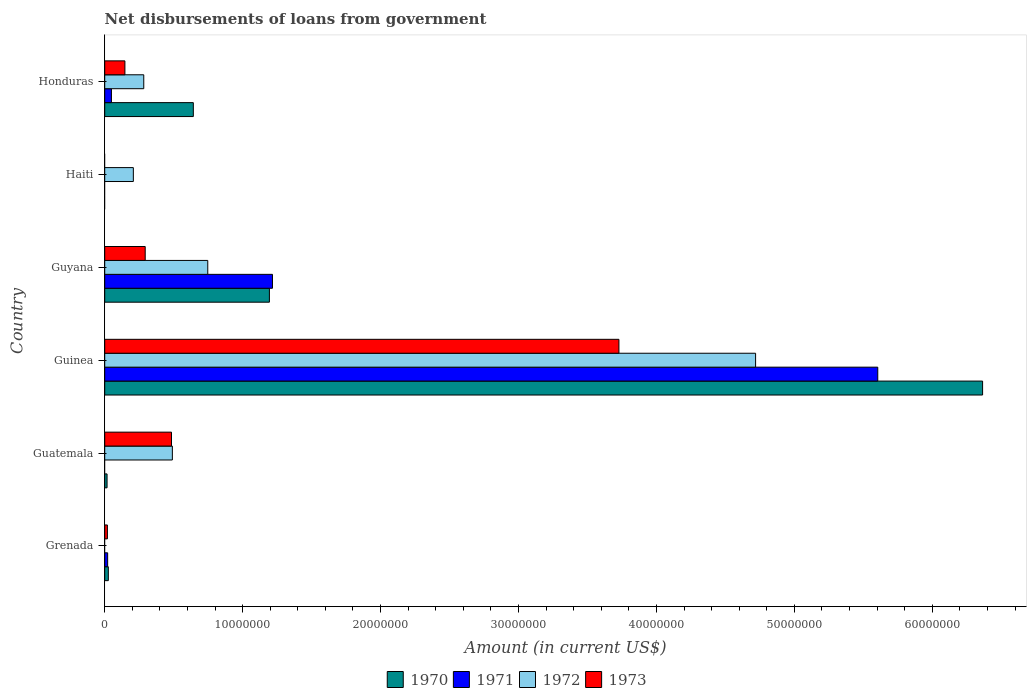Are the number of bars on each tick of the Y-axis equal?
Ensure brevity in your answer.  No. What is the label of the 3rd group of bars from the top?
Offer a terse response. Guyana. In how many cases, is the number of bars for a given country not equal to the number of legend labels?
Offer a very short reply. 3. What is the amount of loan disbursed from government in 1971 in Grenada?
Your answer should be very brief. 2.13e+05. Across all countries, what is the maximum amount of loan disbursed from government in 1970?
Your answer should be very brief. 6.36e+07. In which country was the amount of loan disbursed from government in 1971 maximum?
Your answer should be very brief. Guinea. What is the total amount of loan disbursed from government in 1971 in the graph?
Your answer should be compact. 6.89e+07. What is the difference between the amount of loan disbursed from government in 1972 in Guatemala and that in Guyana?
Ensure brevity in your answer.  -2.57e+06. What is the difference between the amount of loan disbursed from government in 1972 in Grenada and the amount of loan disbursed from government in 1970 in Honduras?
Provide a short and direct response. -6.42e+06. What is the average amount of loan disbursed from government in 1972 per country?
Provide a short and direct response. 1.07e+07. What is the difference between the amount of loan disbursed from government in 1971 and amount of loan disbursed from government in 1972 in Guyana?
Provide a succinct answer. 4.69e+06. What is the ratio of the amount of loan disbursed from government in 1973 in Guyana to that in Honduras?
Your answer should be compact. 2. What is the difference between the highest and the second highest amount of loan disbursed from government in 1971?
Your answer should be compact. 4.39e+07. What is the difference between the highest and the lowest amount of loan disbursed from government in 1971?
Your response must be concise. 5.60e+07. In how many countries, is the amount of loan disbursed from government in 1970 greater than the average amount of loan disbursed from government in 1970 taken over all countries?
Offer a terse response. 1. Is the sum of the amount of loan disbursed from government in 1973 in Grenada and Guinea greater than the maximum amount of loan disbursed from government in 1970 across all countries?
Offer a very short reply. No. Is it the case that in every country, the sum of the amount of loan disbursed from government in 1971 and amount of loan disbursed from government in 1970 is greater than the amount of loan disbursed from government in 1972?
Offer a very short reply. No. How many countries are there in the graph?
Your response must be concise. 6. What is the difference between two consecutive major ticks on the X-axis?
Your answer should be very brief. 1.00e+07. Are the values on the major ticks of X-axis written in scientific E-notation?
Your answer should be very brief. No. Does the graph contain grids?
Give a very brief answer. No. What is the title of the graph?
Give a very brief answer. Net disbursements of loans from government. Does "2000" appear as one of the legend labels in the graph?
Your answer should be compact. No. What is the label or title of the X-axis?
Offer a terse response. Amount (in current US$). What is the label or title of the Y-axis?
Your response must be concise. Country. What is the Amount (in current US$) in 1970 in Grenada?
Provide a succinct answer. 2.62e+05. What is the Amount (in current US$) of 1971 in Grenada?
Offer a terse response. 2.13e+05. What is the Amount (in current US$) in 1972 in Grenada?
Your answer should be compact. 0. What is the Amount (in current US$) of 1973 in Grenada?
Provide a short and direct response. 1.95e+05. What is the Amount (in current US$) in 1972 in Guatemala?
Provide a succinct answer. 4.90e+06. What is the Amount (in current US$) of 1973 in Guatemala?
Give a very brief answer. 4.84e+06. What is the Amount (in current US$) in 1970 in Guinea?
Your answer should be very brief. 6.36e+07. What is the Amount (in current US$) in 1971 in Guinea?
Your response must be concise. 5.60e+07. What is the Amount (in current US$) of 1972 in Guinea?
Your answer should be compact. 4.72e+07. What is the Amount (in current US$) of 1973 in Guinea?
Make the answer very short. 3.73e+07. What is the Amount (in current US$) in 1970 in Guyana?
Offer a very short reply. 1.19e+07. What is the Amount (in current US$) of 1971 in Guyana?
Offer a terse response. 1.22e+07. What is the Amount (in current US$) of 1972 in Guyana?
Keep it short and to the point. 7.47e+06. What is the Amount (in current US$) in 1973 in Guyana?
Give a very brief answer. 2.94e+06. What is the Amount (in current US$) in 1970 in Haiti?
Ensure brevity in your answer.  0. What is the Amount (in current US$) in 1972 in Haiti?
Provide a succinct answer. 2.08e+06. What is the Amount (in current US$) of 1970 in Honduras?
Offer a very short reply. 6.42e+06. What is the Amount (in current US$) in 1971 in Honduras?
Make the answer very short. 4.87e+05. What is the Amount (in current US$) of 1972 in Honduras?
Give a very brief answer. 2.83e+06. What is the Amount (in current US$) in 1973 in Honduras?
Ensure brevity in your answer.  1.46e+06. Across all countries, what is the maximum Amount (in current US$) in 1970?
Ensure brevity in your answer.  6.36e+07. Across all countries, what is the maximum Amount (in current US$) of 1971?
Your answer should be very brief. 5.60e+07. Across all countries, what is the maximum Amount (in current US$) in 1972?
Ensure brevity in your answer.  4.72e+07. Across all countries, what is the maximum Amount (in current US$) of 1973?
Ensure brevity in your answer.  3.73e+07. Across all countries, what is the minimum Amount (in current US$) of 1970?
Ensure brevity in your answer.  0. Across all countries, what is the minimum Amount (in current US$) in 1972?
Keep it short and to the point. 0. Across all countries, what is the minimum Amount (in current US$) of 1973?
Provide a short and direct response. 0. What is the total Amount (in current US$) of 1970 in the graph?
Make the answer very short. 8.24e+07. What is the total Amount (in current US$) in 1971 in the graph?
Keep it short and to the point. 6.89e+07. What is the total Amount (in current US$) in 1972 in the graph?
Offer a very short reply. 6.45e+07. What is the total Amount (in current US$) in 1973 in the graph?
Your response must be concise. 4.67e+07. What is the difference between the Amount (in current US$) of 1970 in Grenada and that in Guatemala?
Your answer should be very brief. 9.20e+04. What is the difference between the Amount (in current US$) of 1973 in Grenada and that in Guatemala?
Your response must be concise. -4.65e+06. What is the difference between the Amount (in current US$) in 1970 in Grenada and that in Guinea?
Make the answer very short. -6.34e+07. What is the difference between the Amount (in current US$) of 1971 in Grenada and that in Guinea?
Your answer should be very brief. -5.58e+07. What is the difference between the Amount (in current US$) in 1973 in Grenada and that in Guinea?
Offer a terse response. -3.71e+07. What is the difference between the Amount (in current US$) in 1970 in Grenada and that in Guyana?
Your answer should be compact. -1.17e+07. What is the difference between the Amount (in current US$) of 1971 in Grenada and that in Guyana?
Ensure brevity in your answer.  -1.19e+07. What is the difference between the Amount (in current US$) in 1973 in Grenada and that in Guyana?
Ensure brevity in your answer.  -2.74e+06. What is the difference between the Amount (in current US$) in 1970 in Grenada and that in Honduras?
Make the answer very short. -6.16e+06. What is the difference between the Amount (in current US$) of 1971 in Grenada and that in Honduras?
Your answer should be very brief. -2.74e+05. What is the difference between the Amount (in current US$) of 1973 in Grenada and that in Honduras?
Your response must be concise. -1.27e+06. What is the difference between the Amount (in current US$) in 1970 in Guatemala and that in Guinea?
Offer a very short reply. -6.35e+07. What is the difference between the Amount (in current US$) of 1972 in Guatemala and that in Guinea?
Your response must be concise. -4.23e+07. What is the difference between the Amount (in current US$) in 1973 in Guatemala and that in Guinea?
Ensure brevity in your answer.  -3.24e+07. What is the difference between the Amount (in current US$) of 1970 in Guatemala and that in Guyana?
Make the answer very short. -1.18e+07. What is the difference between the Amount (in current US$) of 1972 in Guatemala and that in Guyana?
Ensure brevity in your answer.  -2.57e+06. What is the difference between the Amount (in current US$) in 1973 in Guatemala and that in Guyana?
Your answer should be very brief. 1.91e+06. What is the difference between the Amount (in current US$) in 1972 in Guatemala and that in Haiti?
Your response must be concise. 2.83e+06. What is the difference between the Amount (in current US$) in 1970 in Guatemala and that in Honduras?
Make the answer very short. -6.25e+06. What is the difference between the Amount (in current US$) in 1972 in Guatemala and that in Honduras?
Keep it short and to the point. 2.07e+06. What is the difference between the Amount (in current US$) in 1973 in Guatemala and that in Honduras?
Your answer should be very brief. 3.38e+06. What is the difference between the Amount (in current US$) of 1970 in Guinea and that in Guyana?
Your response must be concise. 5.17e+07. What is the difference between the Amount (in current US$) of 1971 in Guinea and that in Guyana?
Give a very brief answer. 4.39e+07. What is the difference between the Amount (in current US$) in 1972 in Guinea and that in Guyana?
Give a very brief answer. 3.97e+07. What is the difference between the Amount (in current US$) in 1973 in Guinea and that in Guyana?
Your response must be concise. 3.43e+07. What is the difference between the Amount (in current US$) in 1972 in Guinea and that in Haiti?
Provide a succinct answer. 4.51e+07. What is the difference between the Amount (in current US$) of 1970 in Guinea and that in Honduras?
Give a very brief answer. 5.72e+07. What is the difference between the Amount (in current US$) in 1971 in Guinea and that in Honduras?
Ensure brevity in your answer.  5.56e+07. What is the difference between the Amount (in current US$) of 1972 in Guinea and that in Honduras?
Offer a terse response. 4.44e+07. What is the difference between the Amount (in current US$) of 1973 in Guinea and that in Honduras?
Provide a short and direct response. 3.58e+07. What is the difference between the Amount (in current US$) in 1972 in Guyana and that in Haiti?
Your answer should be compact. 5.40e+06. What is the difference between the Amount (in current US$) in 1970 in Guyana and that in Honduras?
Give a very brief answer. 5.52e+06. What is the difference between the Amount (in current US$) in 1971 in Guyana and that in Honduras?
Offer a very short reply. 1.17e+07. What is the difference between the Amount (in current US$) in 1972 in Guyana and that in Honduras?
Offer a terse response. 4.64e+06. What is the difference between the Amount (in current US$) of 1973 in Guyana and that in Honduras?
Your answer should be compact. 1.47e+06. What is the difference between the Amount (in current US$) in 1972 in Haiti and that in Honduras?
Your answer should be compact. -7.55e+05. What is the difference between the Amount (in current US$) of 1970 in Grenada and the Amount (in current US$) of 1972 in Guatemala?
Ensure brevity in your answer.  -4.64e+06. What is the difference between the Amount (in current US$) in 1970 in Grenada and the Amount (in current US$) in 1973 in Guatemala?
Your response must be concise. -4.58e+06. What is the difference between the Amount (in current US$) in 1971 in Grenada and the Amount (in current US$) in 1972 in Guatemala?
Your answer should be very brief. -4.69e+06. What is the difference between the Amount (in current US$) of 1971 in Grenada and the Amount (in current US$) of 1973 in Guatemala?
Offer a terse response. -4.63e+06. What is the difference between the Amount (in current US$) in 1970 in Grenada and the Amount (in current US$) in 1971 in Guinea?
Give a very brief answer. -5.58e+07. What is the difference between the Amount (in current US$) in 1970 in Grenada and the Amount (in current US$) in 1972 in Guinea?
Ensure brevity in your answer.  -4.69e+07. What is the difference between the Amount (in current US$) of 1970 in Grenada and the Amount (in current US$) of 1973 in Guinea?
Give a very brief answer. -3.70e+07. What is the difference between the Amount (in current US$) in 1971 in Grenada and the Amount (in current US$) in 1972 in Guinea?
Ensure brevity in your answer.  -4.70e+07. What is the difference between the Amount (in current US$) of 1971 in Grenada and the Amount (in current US$) of 1973 in Guinea?
Offer a very short reply. -3.71e+07. What is the difference between the Amount (in current US$) in 1970 in Grenada and the Amount (in current US$) in 1971 in Guyana?
Ensure brevity in your answer.  -1.19e+07. What is the difference between the Amount (in current US$) of 1970 in Grenada and the Amount (in current US$) of 1972 in Guyana?
Keep it short and to the point. -7.21e+06. What is the difference between the Amount (in current US$) in 1970 in Grenada and the Amount (in current US$) in 1973 in Guyana?
Provide a short and direct response. -2.67e+06. What is the difference between the Amount (in current US$) in 1971 in Grenada and the Amount (in current US$) in 1972 in Guyana?
Make the answer very short. -7.26e+06. What is the difference between the Amount (in current US$) in 1971 in Grenada and the Amount (in current US$) in 1973 in Guyana?
Offer a terse response. -2.72e+06. What is the difference between the Amount (in current US$) in 1970 in Grenada and the Amount (in current US$) in 1972 in Haiti?
Your answer should be compact. -1.81e+06. What is the difference between the Amount (in current US$) in 1971 in Grenada and the Amount (in current US$) in 1972 in Haiti?
Your response must be concise. -1.86e+06. What is the difference between the Amount (in current US$) in 1970 in Grenada and the Amount (in current US$) in 1971 in Honduras?
Offer a terse response. -2.25e+05. What is the difference between the Amount (in current US$) of 1970 in Grenada and the Amount (in current US$) of 1972 in Honduras?
Provide a succinct answer. -2.57e+06. What is the difference between the Amount (in current US$) in 1970 in Grenada and the Amount (in current US$) in 1973 in Honduras?
Your response must be concise. -1.20e+06. What is the difference between the Amount (in current US$) of 1971 in Grenada and the Amount (in current US$) of 1972 in Honduras?
Keep it short and to the point. -2.62e+06. What is the difference between the Amount (in current US$) of 1971 in Grenada and the Amount (in current US$) of 1973 in Honduras?
Offer a terse response. -1.25e+06. What is the difference between the Amount (in current US$) of 1970 in Guatemala and the Amount (in current US$) of 1971 in Guinea?
Provide a succinct answer. -5.59e+07. What is the difference between the Amount (in current US$) in 1970 in Guatemala and the Amount (in current US$) in 1972 in Guinea?
Your answer should be very brief. -4.70e+07. What is the difference between the Amount (in current US$) of 1970 in Guatemala and the Amount (in current US$) of 1973 in Guinea?
Offer a very short reply. -3.71e+07. What is the difference between the Amount (in current US$) in 1972 in Guatemala and the Amount (in current US$) in 1973 in Guinea?
Provide a short and direct response. -3.24e+07. What is the difference between the Amount (in current US$) in 1970 in Guatemala and the Amount (in current US$) in 1971 in Guyana?
Provide a succinct answer. -1.20e+07. What is the difference between the Amount (in current US$) in 1970 in Guatemala and the Amount (in current US$) in 1972 in Guyana?
Provide a succinct answer. -7.30e+06. What is the difference between the Amount (in current US$) of 1970 in Guatemala and the Amount (in current US$) of 1973 in Guyana?
Your response must be concise. -2.76e+06. What is the difference between the Amount (in current US$) of 1972 in Guatemala and the Amount (in current US$) of 1973 in Guyana?
Your answer should be very brief. 1.97e+06. What is the difference between the Amount (in current US$) of 1970 in Guatemala and the Amount (in current US$) of 1972 in Haiti?
Keep it short and to the point. -1.91e+06. What is the difference between the Amount (in current US$) in 1970 in Guatemala and the Amount (in current US$) in 1971 in Honduras?
Provide a short and direct response. -3.17e+05. What is the difference between the Amount (in current US$) of 1970 in Guatemala and the Amount (in current US$) of 1972 in Honduras?
Your answer should be compact. -2.66e+06. What is the difference between the Amount (in current US$) in 1970 in Guatemala and the Amount (in current US$) in 1973 in Honduras?
Keep it short and to the point. -1.29e+06. What is the difference between the Amount (in current US$) in 1972 in Guatemala and the Amount (in current US$) in 1973 in Honduras?
Ensure brevity in your answer.  3.44e+06. What is the difference between the Amount (in current US$) in 1970 in Guinea and the Amount (in current US$) in 1971 in Guyana?
Offer a terse response. 5.15e+07. What is the difference between the Amount (in current US$) in 1970 in Guinea and the Amount (in current US$) in 1972 in Guyana?
Offer a very short reply. 5.62e+07. What is the difference between the Amount (in current US$) of 1970 in Guinea and the Amount (in current US$) of 1973 in Guyana?
Provide a succinct answer. 6.07e+07. What is the difference between the Amount (in current US$) in 1971 in Guinea and the Amount (in current US$) in 1972 in Guyana?
Your answer should be very brief. 4.86e+07. What is the difference between the Amount (in current US$) in 1971 in Guinea and the Amount (in current US$) in 1973 in Guyana?
Make the answer very short. 5.31e+07. What is the difference between the Amount (in current US$) in 1972 in Guinea and the Amount (in current US$) in 1973 in Guyana?
Offer a terse response. 4.43e+07. What is the difference between the Amount (in current US$) in 1970 in Guinea and the Amount (in current US$) in 1972 in Haiti?
Provide a short and direct response. 6.16e+07. What is the difference between the Amount (in current US$) of 1971 in Guinea and the Amount (in current US$) of 1972 in Haiti?
Offer a terse response. 5.40e+07. What is the difference between the Amount (in current US$) in 1970 in Guinea and the Amount (in current US$) in 1971 in Honduras?
Offer a very short reply. 6.32e+07. What is the difference between the Amount (in current US$) of 1970 in Guinea and the Amount (in current US$) of 1972 in Honduras?
Provide a succinct answer. 6.08e+07. What is the difference between the Amount (in current US$) of 1970 in Guinea and the Amount (in current US$) of 1973 in Honduras?
Offer a terse response. 6.22e+07. What is the difference between the Amount (in current US$) in 1971 in Guinea and the Amount (in current US$) in 1972 in Honduras?
Offer a terse response. 5.32e+07. What is the difference between the Amount (in current US$) in 1971 in Guinea and the Amount (in current US$) in 1973 in Honduras?
Provide a short and direct response. 5.46e+07. What is the difference between the Amount (in current US$) of 1972 in Guinea and the Amount (in current US$) of 1973 in Honduras?
Provide a short and direct response. 4.57e+07. What is the difference between the Amount (in current US$) of 1970 in Guyana and the Amount (in current US$) of 1972 in Haiti?
Your answer should be compact. 9.86e+06. What is the difference between the Amount (in current US$) of 1971 in Guyana and the Amount (in current US$) of 1972 in Haiti?
Provide a succinct answer. 1.01e+07. What is the difference between the Amount (in current US$) of 1970 in Guyana and the Amount (in current US$) of 1971 in Honduras?
Provide a short and direct response. 1.15e+07. What is the difference between the Amount (in current US$) of 1970 in Guyana and the Amount (in current US$) of 1972 in Honduras?
Give a very brief answer. 9.11e+06. What is the difference between the Amount (in current US$) in 1970 in Guyana and the Amount (in current US$) in 1973 in Honduras?
Keep it short and to the point. 1.05e+07. What is the difference between the Amount (in current US$) in 1971 in Guyana and the Amount (in current US$) in 1972 in Honduras?
Offer a terse response. 9.33e+06. What is the difference between the Amount (in current US$) of 1971 in Guyana and the Amount (in current US$) of 1973 in Honduras?
Provide a short and direct response. 1.07e+07. What is the difference between the Amount (in current US$) in 1972 in Guyana and the Amount (in current US$) in 1973 in Honduras?
Your answer should be compact. 6.01e+06. What is the difference between the Amount (in current US$) of 1972 in Haiti and the Amount (in current US$) of 1973 in Honduras?
Provide a short and direct response. 6.12e+05. What is the average Amount (in current US$) of 1970 per country?
Provide a short and direct response. 1.37e+07. What is the average Amount (in current US$) in 1971 per country?
Offer a terse response. 1.15e+07. What is the average Amount (in current US$) of 1972 per country?
Make the answer very short. 1.07e+07. What is the average Amount (in current US$) in 1973 per country?
Your answer should be very brief. 7.79e+06. What is the difference between the Amount (in current US$) in 1970 and Amount (in current US$) in 1971 in Grenada?
Your answer should be compact. 4.90e+04. What is the difference between the Amount (in current US$) in 1970 and Amount (in current US$) in 1973 in Grenada?
Your answer should be very brief. 6.70e+04. What is the difference between the Amount (in current US$) of 1971 and Amount (in current US$) of 1973 in Grenada?
Provide a succinct answer. 1.80e+04. What is the difference between the Amount (in current US$) in 1970 and Amount (in current US$) in 1972 in Guatemala?
Provide a short and direct response. -4.73e+06. What is the difference between the Amount (in current US$) of 1970 and Amount (in current US$) of 1973 in Guatemala?
Make the answer very short. -4.67e+06. What is the difference between the Amount (in current US$) of 1972 and Amount (in current US$) of 1973 in Guatemala?
Your answer should be very brief. 6.20e+04. What is the difference between the Amount (in current US$) in 1970 and Amount (in current US$) in 1971 in Guinea?
Your response must be concise. 7.60e+06. What is the difference between the Amount (in current US$) in 1970 and Amount (in current US$) in 1972 in Guinea?
Ensure brevity in your answer.  1.65e+07. What is the difference between the Amount (in current US$) in 1970 and Amount (in current US$) in 1973 in Guinea?
Keep it short and to the point. 2.64e+07. What is the difference between the Amount (in current US$) in 1971 and Amount (in current US$) in 1972 in Guinea?
Give a very brief answer. 8.86e+06. What is the difference between the Amount (in current US$) in 1971 and Amount (in current US$) in 1973 in Guinea?
Keep it short and to the point. 1.88e+07. What is the difference between the Amount (in current US$) in 1972 and Amount (in current US$) in 1973 in Guinea?
Ensure brevity in your answer.  9.91e+06. What is the difference between the Amount (in current US$) in 1970 and Amount (in current US$) in 1971 in Guyana?
Your answer should be compact. -2.22e+05. What is the difference between the Amount (in current US$) in 1970 and Amount (in current US$) in 1972 in Guyana?
Your response must be concise. 4.47e+06. What is the difference between the Amount (in current US$) in 1970 and Amount (in current US$) in 1973 in Guyana?
Keep it short and to the point. 9.00e+06. What is the difference between the Amount (in current US$) of 1971 and Amount (in current US$) of 1972 in Guyana?
Ensure brevity in your answer.  4.69e+06. What is the difference between the Amount (in current US$) of 1971 and Amount (in current US$) of 1973 in Guyana?
Ensure brevity in your answer.  9.23e+06. What is the difference between the Amount (in current US$) in 1972 and Amount (in current US$) in 1973 in Guyana?
Give a very brief answer. 4.54e+06. What is the difference between the Amount (in current US$) in 1970 and Amount (in current US$) in 1971 in Honduras?
Ensure brevity in your answer.  5.94e+06. What is the difference between the Amount (in current US$) of 1970 and Amount (in current US$) of 1972 in Honduras?
Your answer should be very brief. 3.59e+06. What is the difference between the Amount (in current US$) in 1970 and Amount (in current US$) in 1973 in Honduras?
Provide a short and direct response. 4.96e+06. What is the difference between the Amount (in current US$) in 1971 and Amount (in current US$) in 1972 in Honduras?
Ensure brevity in your answer.  -2.34e+06. What is the difference between the Amount (in current US$) of 1971 and Amount (in current US$) of 1973 in Honduras?
Your answer should be very brief. -9.77e+05. What is the difference between the Amount (in current US$) in 1972 and Amount (in current US$) in 1973 in Honduras?
Your answer should be compact. 1.37e+06. What is the ratio of the Amount (in current US$) of 1970 in Grenada to that in Guatemala?
Offer a very short reply. 1.54. What is the ratio of the Amount (in current US$) of 1973 in Grenada to that in Guatemala?
Give a very brief answer. 0.04. What is the ratio of the Amount (in current US$) in 1970 in Grenada to that in Guinea?
Your answer should be very brief. 0. What is the ratio of the Amount (in current US$) in 1971 in Grenada to that in Guinea?
Your answer should be very brief. 0. What is the ratio of the Amount (in current US$) of 1973 in Grenada to that in Guinea?
Keep it short and to the point. 0.01. What is the ratio of the Amount (in current US$) of 1970 in Grenada to that in Guyana?
Make the answer very short. 0.02. What is the ratio of the Amount (in current US$) in 1971 in Grenada to that in Guyana?
Offer a very short reply. 0.02. What is the ratio of the Amount (in current US$) in 1973 in Grenada to that in Guyana?
Provide a succinct answer. 0.07. What is the ratio of the Amount (in current US$) in 1970 in Grenada to that in Honduras?
Keep it short and to the point. 0.04. What is the ratio of the Amount (in current US$) in 1971 in Grenada to that in Honduras?
Make the answer very short. 0.44. What is the ratio of the Amount (in current US$) of 1973 in Grenada to that in Honduras?
Keep it short and to the point. 0.13. What is the ratio of the Amount (in current US$) in 1970 in Guatemala to that in Guinea?
Offer a terse response. 0. What is the ratio of the Amount (in current US$) of 1972 in Guatemala to that in Guinea?
Your response must be concise. 0.1. What is the ratio of the Amount (in current US$) in 1973 in Guatemala to that in Guinea?
Give a very brief answer. 0.13. What is the ratio of the Amount (in current US$) of 1970 in Guatemala to that in Guyana?
Your response must be concise. 0.01. What is the ratio of the Amount (in current US$) in 1972 in Guatemala to that in Guyana?
Offer a very short reply. 0.66. What is the ratio of the Amount (in current US$) of 1973 in Guatemala to that in Guyana?
Your answer should be very brief. 1.65. What is the ratio of the Amount (in current US$) in 1972 in Guatemala to that in Haiti?
Offer a terse response. 2.36. What is the ratio of the Amount (in current US$) in 1970 in Guatemala to that in Honduras?
Your answer should be compact. 0.03. What is the ratio of the Amount (in current US$) of 1972 in Guatemala to that in Honduras?
Make the answer very short. 1.73. What is the ratio of the Amount (in current US$) in 1973 in Guatemala to that in Honduras?
Make the answer very short. 3.31. What is the ratio of the Amount (in current US$) in 1970 in Guinea to that in Guyana?
Give a very brief answer. 5.33. What is the ratio of the Amount (in current US$) in 1971 in Guinea to that in Guyana?
Make the answer very short. 4.61. What is the ratio of the Amount (in current US$) of 1972 in Guinea to that in Guyana?
Ensure brevity in your answer.  6.32. What is the ratio of the Amount (in current US$) in 1973 in Guinea to that in Guyana?
Your answer should be compact. 12.7. What is the ratio of the Amount (in current US$) in 1972 in Guinea to that in Haiti?
Keep it short and to the point. 22.73. What is the ratio of the Amount (in current US$) in 1970 in Guinea to that in Honduras?
Offer a very short reply. 9.91. What is the ratio of the Amount (in current US$) of 1971 in Guinea to that in Honduras?
Provide a short and direct response. 115.09. What is the ratio of the Amount (in current US$) of 1972 in Guinea to that in Honduras?
Provide a short and direct response. 16.67. What is the ratio of the Amount (in current US$) in 1973 in Guinea to that in Honduras?
Offer a terse response. 25.47. What is the ratio of the Amount (in current US$) in 1972 in Guyana to that in Haiti?
Make the answer very short. 3.6. What is the ratio of the Amount (in current US$) of 1970 in Guyana to that in Honduras?
Ensure brevity in your answer.  1.86. What is the ratio of the Amount (in current US$) of 1971 in Guyana to that in Honduras?
Provide a short and direct response. 24.97. What is the ratio of the Amount (in current US$) in 1972 in Guyana to that in Honduras?
Make the answer very short. 2.64. What is the ratio of the Amount (in current US$) in 1973 in Guyana to that in Honduras?
Your answer should be very brief. 2. What is the ratio of the Amount (in current US$) in 1972 in Haiti to that in Honduras?
Keep it short and to the point. 0.73. What is the difference between the highest and the second highest Amount (in current US$) of 1970?
Your response must be concise. 5.17e+07. What is the difference between the highest and the second highest Amount (in current US$) of 1971?
Your answer should be very brief. 4.39e+07. What is the difference between the highest and the second highest Amount (in current US$) of 1972?
Provide a short and direct response. 3.97e+07. What is the difference between the highest and the second highest Amount (in current US$) of 1973?
Offer a very short reply. 3.24e+07. What is the difference between the highest and the lowest Amount (in current US$) in 1970?
Your answer should be very brief. 6.36e+07. What is the difference between the highest and the lowest Amount (in current US$) of 1971?
Your answer should be very brief. 5.60e+07. What is the difference between the highest and the lowest Amount (in current US$) in 1972?
Make the answer very short. 4.72e+07. What is the difference between the highest and the lowest Amount (in current US$) of 1973?
Offer a terse response. 3.73e+07. 